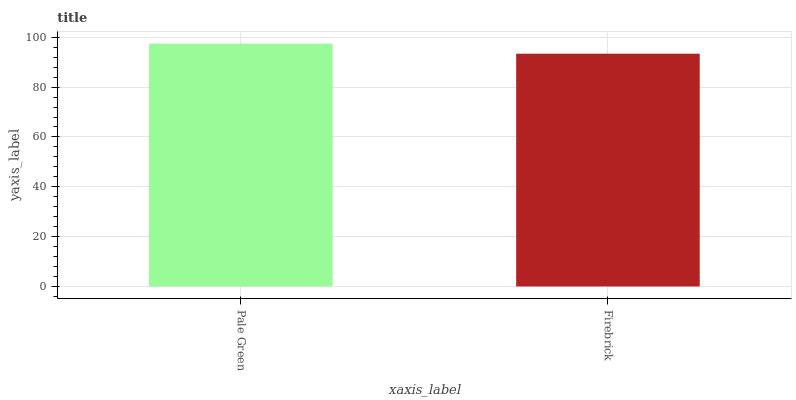Is Firebrick the maximum?
Answer yes or no. No. Is Pale Green greater than Firebrick?
Answer yes or no. Yes. Is Firebrick less than Pale Green?
Answer yes or no. Yes. Is Firebrick greater than Pale Green?
Answer yes or no. No. Is Pale Green less than Firebrick?
Answer yes or no. No. Is Pale Green the high median?
Answer yes or no. Yes. Is Firebrick the low median?
Answer yes or no. Yes. Is Firebrick the high median?
Answer yes or no. No. Is Pale Green the low median?
Answer yes or no. No. 